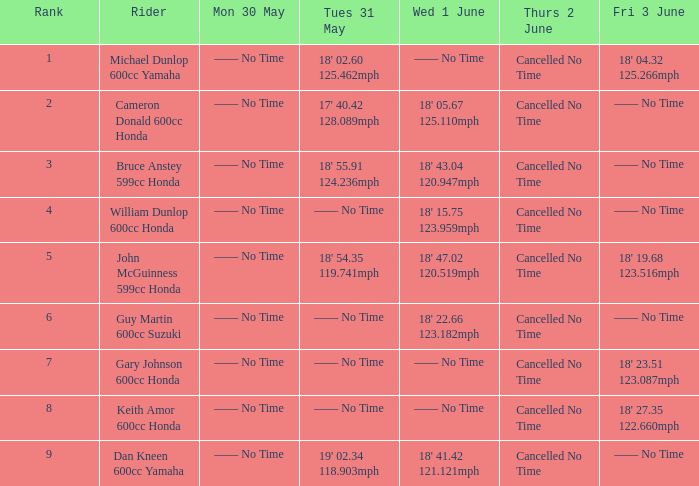If a rider's time was 18' 22.66 with a speed of 123.182 mph on wednesday, june 1, what would be their time on friday —— No Time. 